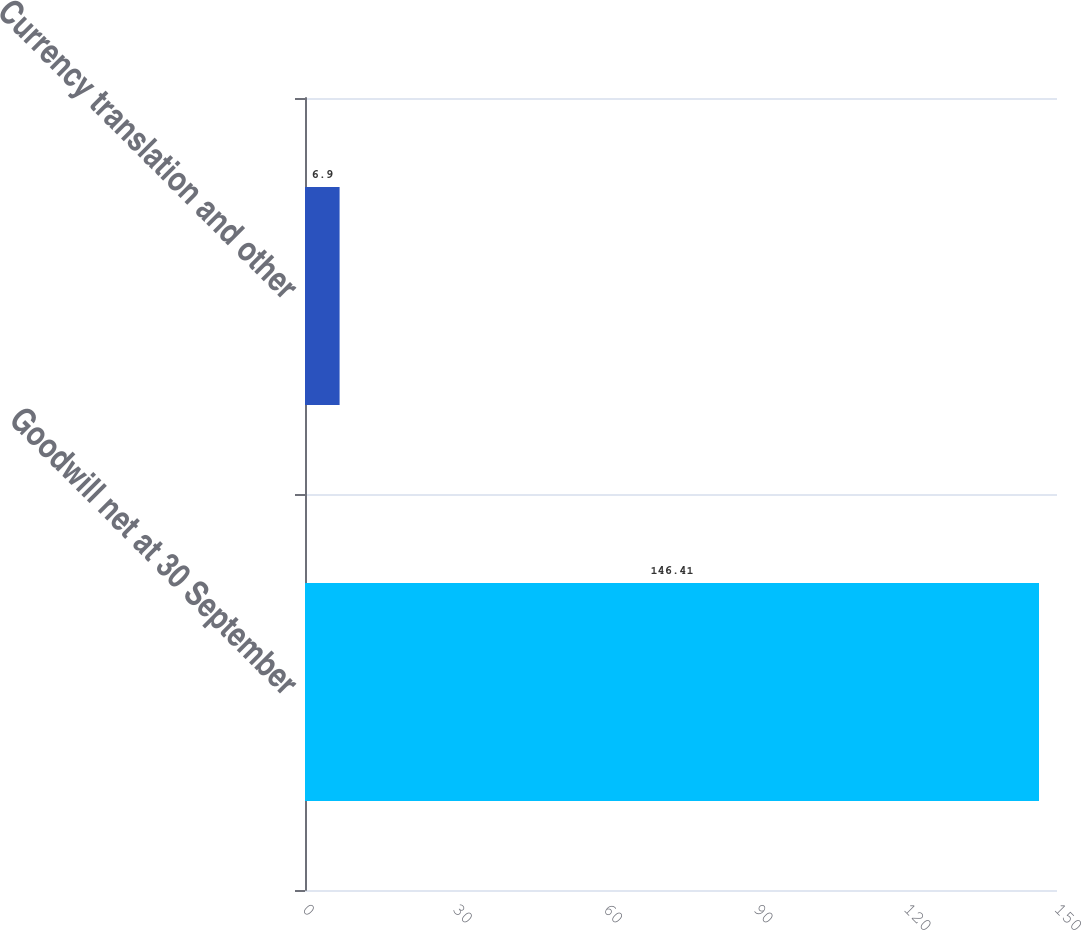Convert chart. <chart><loc_0><loc_0><loc_500><loc_500><bar_chart><fcel>Goodwill net at 30 September<fcel>Currency translation and other<nl><fcel>146.41<fcel>6.9<nl></chart> 